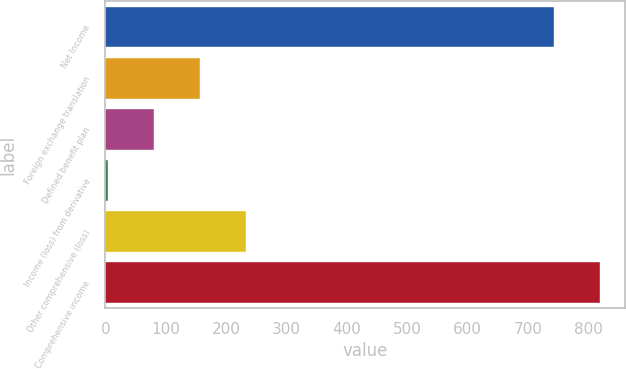Convert chart. <chart><loc_0><loc_0><loc_500><loc_500><bar_chart><fcel>Net Income<fcel>Foreign exchange translation<fcel>Defined benefit plan<fcel>Income (loss) from derivative<fcel>Other comprehensive (loss)<fcel>Comprehensive income<nl><fcel>743.4<fcel>157.04<fcel>80.32<fcel>3.6<fcel>233.76<fcel>820.12<nl></chart> 